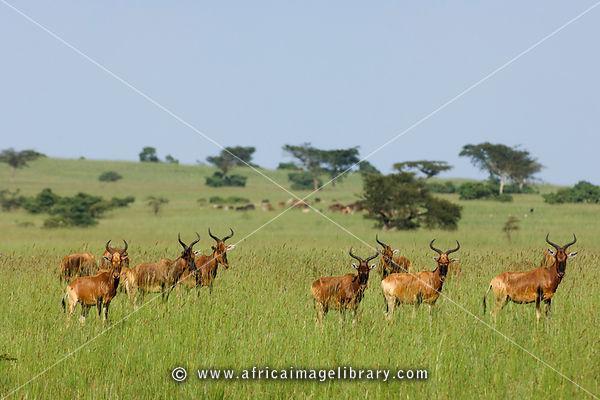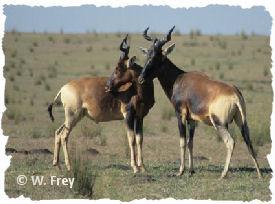The first image is the image on the left, the second image is the image on the right. Considering the images on both sides, is "One of the images features an animal facing left with it's head turned straight." valid? Answer yes or no. No. 